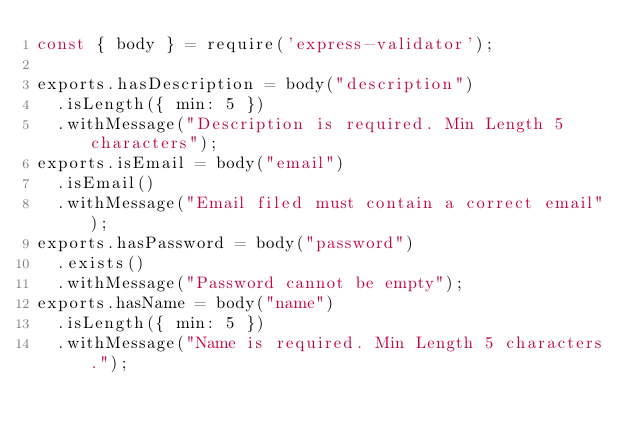Convert code to text. <code><loc_0><loc_0><loc_500><loc_500><_JavaScript_>const { body } = require('express-validator');

exports.hasDescription = body("description")
  .isLength({ min: 5 })
  .withMessage("Description is required. Min Length 5 characters");
exports.isEmail = body("email")
  .isEmail()
  .withMessage("Email filed must contain a correct email");
exports.hasPassword = body("password")
  .exists()
  .withMessage("Password cannot be empty");
exports.hasName = body("name")
  .isLength({ min: 5 })
  .withMessage("Name is required. Min Length 5 characters.");</code> 